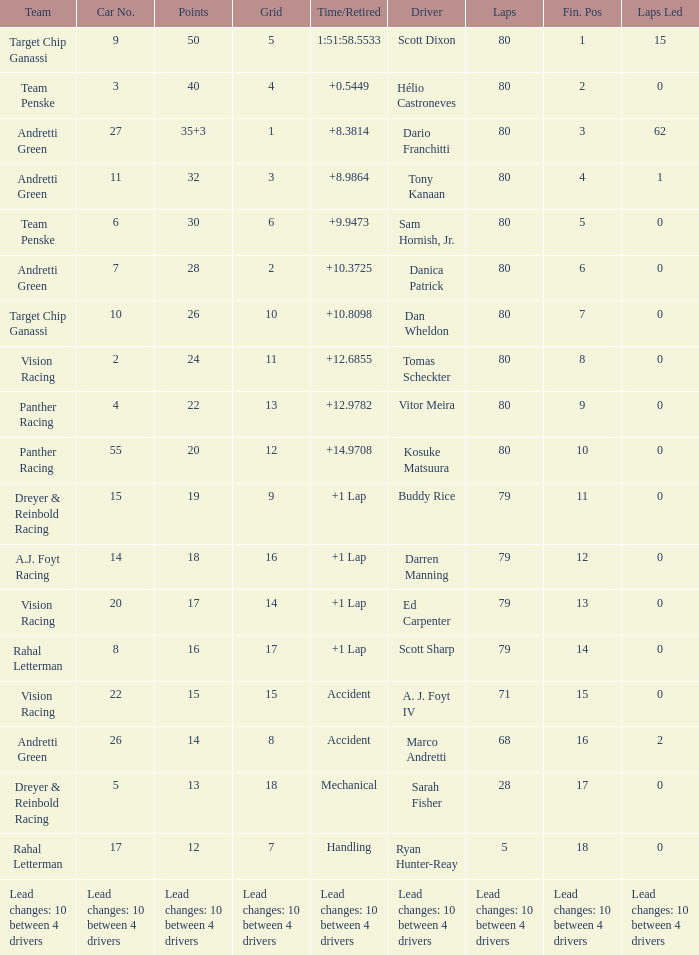Which team has 26 points? Target Chip Ganassi. 